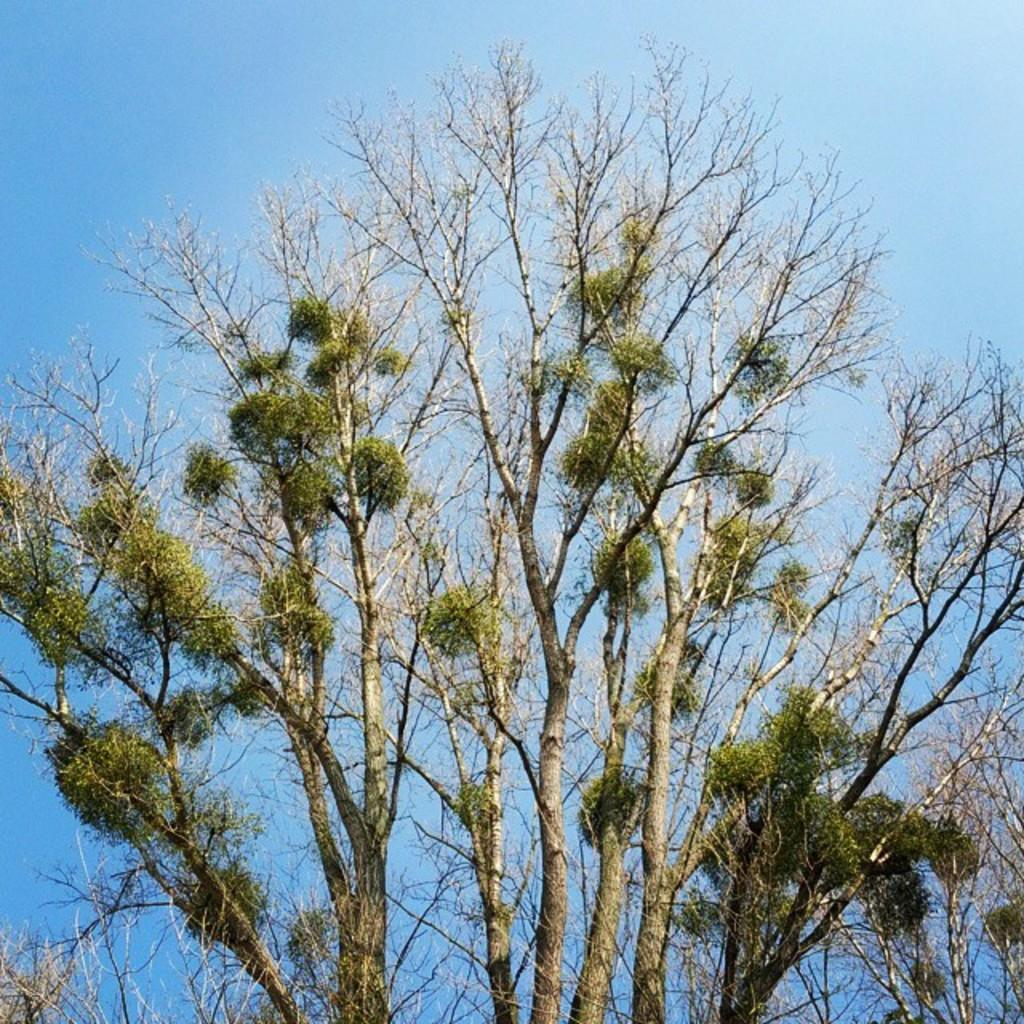What is the main object in the foreground of the image? There is a tree in the image, and it is in the front of the image. What can be seen above the tree in the image? The sky is visible above the tree in the image. What type of mint plant can be seen growing near the tree in the image? There is no mint plant visible in the image; only the tree is present. Is there a crib or baby bed in the image? No, there is no crib or baby bed in the image. 